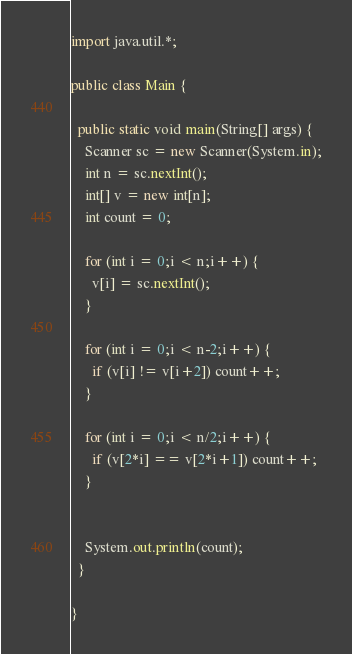Convert code to text. <code><loc_0><loc_0><loc_500><loc_500><_Java_>import java.util.*;

public class Main {

  public static void main(String[] args) {
    Scanner sc = new Scanner(System.in);
    int n = sc.nextInt();
    int[] v = new int[n];
    int count = 0;

    for (int i = 0;i < n;i++) {
      v[i] = sc.nextInt();
    }

    for (int i = 0;i < n-2;i++) {
      if (v[i] != v[i+2]) count++;
    }

    for (int i = 0;i < n/2;i++) {
      if (v[2*i] == v[2*i+1]) count++;
    }


    System.out.println(count);
  }

}
</code> 